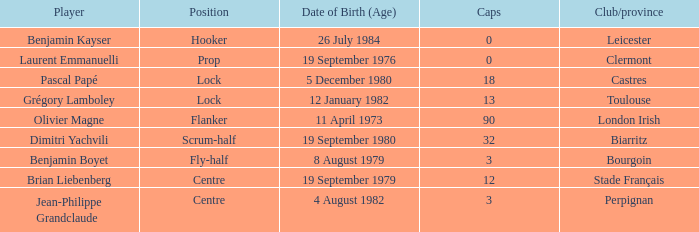What is the birthday of caps of 32? 19 September 1980. 